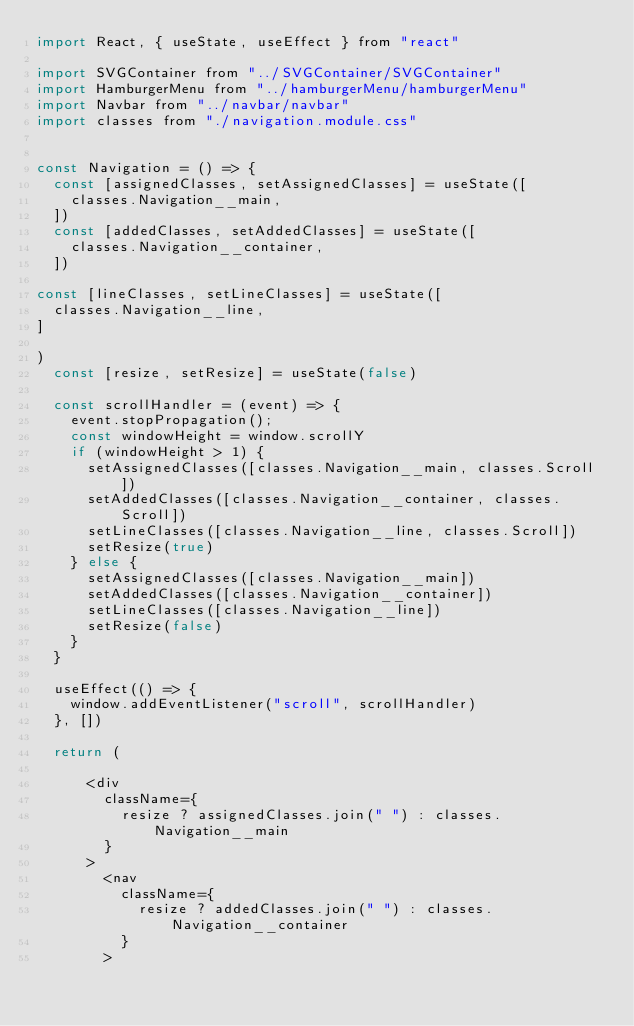Convert code to text. <code><loc_0><loc_0><loc_500><loc_500><_JavaScript_>import React, { useState, useEffect } from "react"

import SVGContainer from "../SVGContainer/SVGContainer"
import HamburgerMenu from "../hamburgerMenu/hamburgerMenu"
import Navbar from "../navbar/navbar"
import classes from "./navigation.module.css"


const Navigation = () => {
  const [assignedClasses, setAssignedClasses] = useState([
    classes.Navigation__main,
  ])
  const [addedClasses, setAddedClasses] = useState([
    classes.Navigation__container,
  ])

const [lineClasses, setLineClasses] = useState([
  classes.Navigation__line,
]

)
  const [resize, setResize] = useState(false)

  const scrollHandler = (event) => {
    event.stopPropagation();
    const windowHeight = window.scrollY
    if (windowHeight > 1) {
      setAssignedClasses([classes.Navigation__main, classes.Scroll])
      setAddedClasses([classes.Navigation__container, classes.Scroll])
      setLineClasses([classes.Navigation__line, classes.Scroll])
      setResize(true)
    } else {
      setAssignedClasses([classes.Navigation__main])
      setAddedClasses([classes.Navigation__container])
      setLineClasses([classes.Navigation__line])
      setResize(false)
    }
  }

  useEffect(() => {
    window.addEventListener("scroll", scrollHandler)
  }, [])

  return (
    
      <div
        className={
          resize ? assignedClasses.join(" ") : classes.Navigation__main
        }
      >
        <nav
          className={
            resize ? addedClasses.join(" ") : classes.Navigation__container
          }
        ></code> 